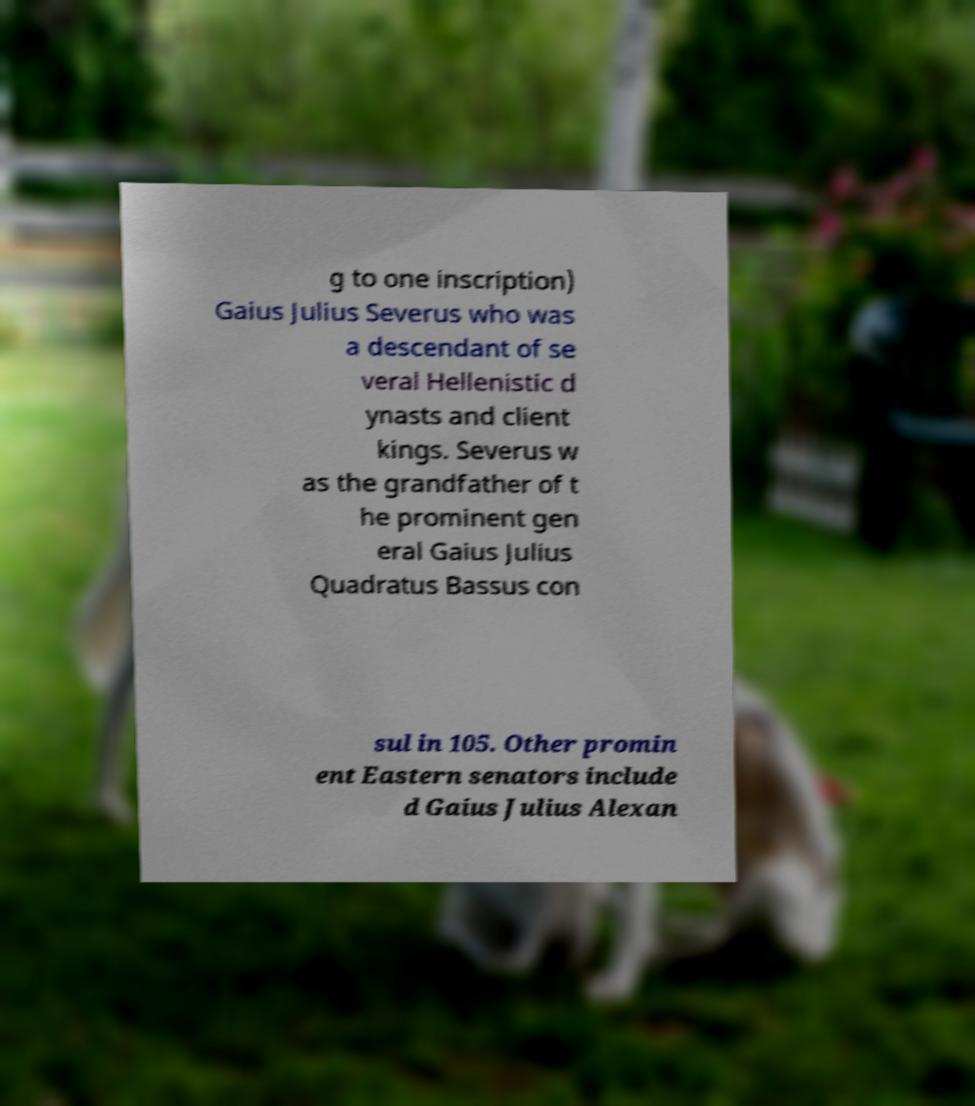Could you assist in decoding the text presented in this image and type it out clearly? g to one inscription) Gaius Julius Severus who was a descendant of se veral Hellenistic d ynasts and client kings. Severus w as the grandfather of t he prominent gen eral Gaius Julius Quadratus Bassus con sul in 105. Other promin ent Eastern senators include d Gaius Julius Alexan 